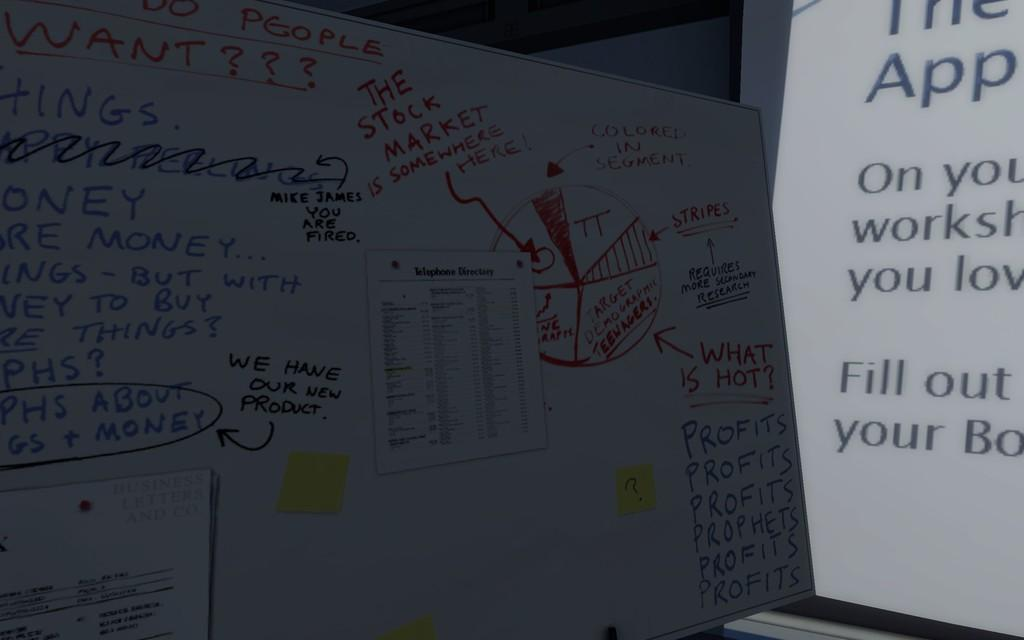Provide a one-sentence caption for the provided image. A whiteboard covered in writing and scribbles with the words "We have our new product!" written in the center. 